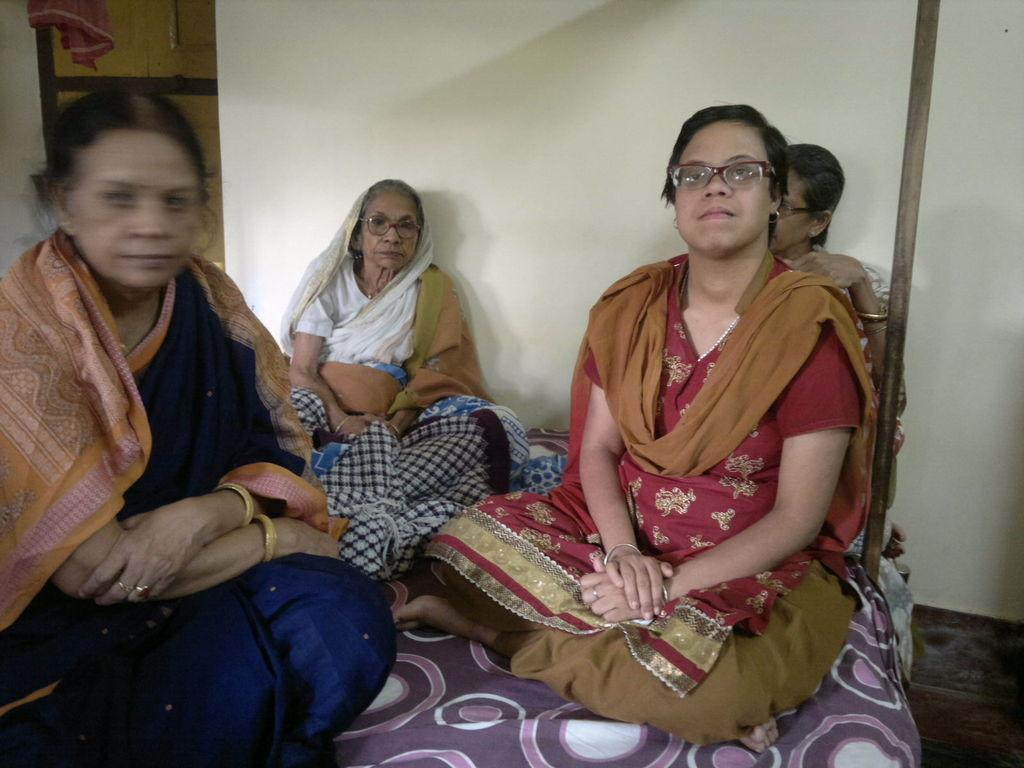How many people are sitting on the bed in the image? There are four people sitting on the bed in the image. What can be seen in the background of the image? There is a wall, a door, and cloth visible in the background of the image. What type of screw can be seen in the image? There is no screw present in the image. What creature is visible in the image? There is no creature visible in the image. 